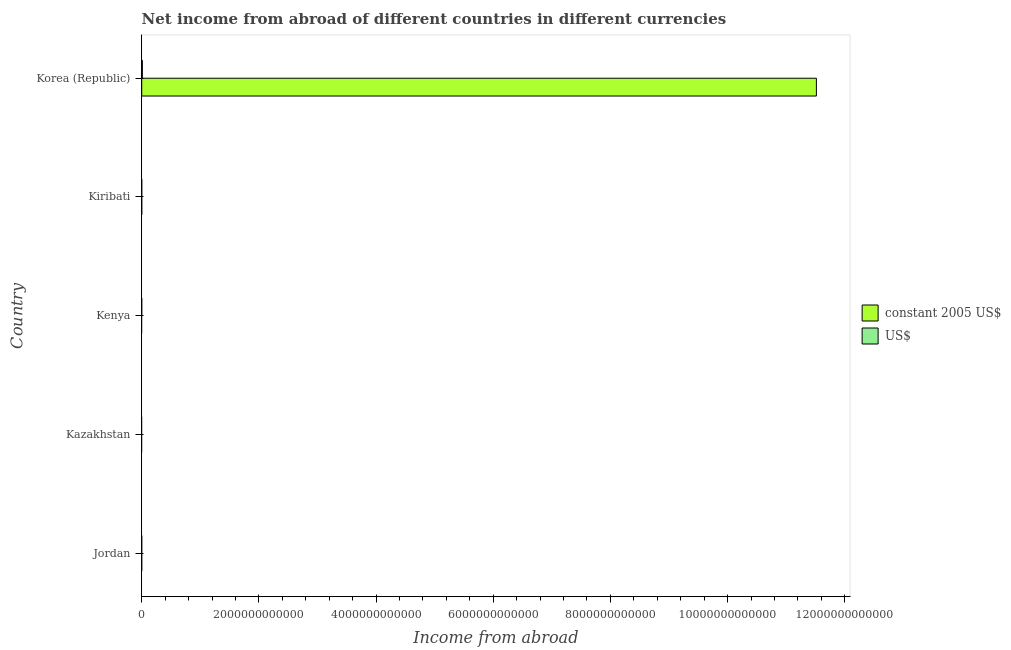How many different coloured bars are there?
Offer a terse response. 2. Are the number of bars per tick equal to the number of legend labels?
Make the answer very short. No. What is the label of the 2nd group of bars from the top?
Your answer should be compact. Kiribati. In how many cases, is the number of bars for a given country not equal to the number of legend labels?
Ensure brevity in your answer.  3. Across all countries, what is the maximum income from abroad in constant 2005 us$?
Offer a very short reply. 1.15e+13. In which country was the income from abroad in us$ maximum?
Give a very brief answer. Korea (Republic). What is the total income from abroad in us$ in the graph?
Provide a short and direct response. 1.11e+1. What is the difference between the income from abroad in us$ in Kiribati and that in Korea (Republic)?
Keep it short and to the point. -1.08e+1. What is the difference between the income from abroad in constant 2005 us$ in Kenya and the income from abroad in us$ in Kiribati?
Your response must be concise. -1.41e+08. What is the average income from abroad in constant 2005 us$ per country?
Ensure brevity in your answer.  2.30e+12. What is the difference between the income from abroad in us$ and income from abroad in constant 2005 us$ in Kiribati?
Offer a terse response. -1.55e+07. In how many countries, is the income from abroad in us$ greater than 5600000000000 units?
Make the answer very short. 0. What is the difference between the highest and the lowest income from abroad in constant 2005 us$?
Provide a short and direct response. 1.15e+13. In how many countries, is the income from abroad in constant 2005 us$ greater than the average income from abroad in constant 2005 us$ taken over all countries?
Your answer should be compact. 1. Are all the bars in the graph horizontal?
Make the answer very short. Yes. How many countries are there in the graph?
Give a very brief answer. 5. What is the difference between two consecutive major ticks on the X-axis?
Offer a terse response. 2.00e+12. Does the graph contain any zero values?
Offer a very short reply. Yes. What is the title of the graph?
Keep it short and to the point. Net income from abroad of different countries in different currencies. Does "Non-resident workers" appear as one of the legend labels in the graph?
Your response must be concise. No. What is the label or title of the X-axis?
Ensure brevity in your answer.  Income from abroad. What is the Income from abroad in constant 2005 US$ in Jordan?
Your answer should be very brief. 0. What is the Income from abroad in US$ in Jordan?
Your answer should be very brief. 0. What is the Income from abroad of US$ in Kazakhstan?
Provide a short and direct response. 0. What is the Income from abroad in constant 2005 US$ in Kenya?
Provide a short and direct response. 0. What is the Income from abroad in US$ in Kenya?
Give a very brief answer. 0. What is the Income from abroad of constant 2005 US$ in Kiribati?
Ensure brevity in your answer.  1.57e+08. What is the Income from abroad of US$ in Kiribati?
Your answer should be very brief. 1.41e+08. What is the Income from abroad of constant 2005 US$ in Korea (Republic)?
Give a very brief answer. 1.15e+13. What is the Income from abroad in US$ in Korea (Republic)?
Make the answer very short. 1.09e+1. Across all countries, what is the maximum Income from abroad in constant 2005 US$?
Your response must be concise. 1.15e+13. Across all countries, what is the maximum Income from abroad of US$?
Provide a succinct answer. 1.09e+1. What is the total Income from abroad in constant 2005 US$ in the graph?
Your answer should be very brief. 1.15e+13. What is the total Income from abroad of US$ in the graph?
Provide a short and direct response. 1.11e+1. What is the difference between the Income from abroad in constant 2005 US$ in Kiribati and that in Korea (Republic)?
Ensure brevity in your answer.  -1.15e+13. What is the difference between the Income from abroad in US$ in Kiribati and that in Korea (Republic)?
Your answer should be very brief. -1.08e+1. What is the difference between the Income from abroad of constant 2005 US$ in Kiribati and the Income from abroad of US$ in Korea (Republic)?
Your response must be concise. -1.08e+1. What is the average Income from abroad of constant 2005 US$ per country?
Your answer should be compact. 2.30e+12. What is the average Income from abroad in US$ per country?
Make the answer very short. 2.22e+09. What is the difference between the Income from abroad in constant 2005 US$ and Income from abroad in US$ in Kiribati?
Provide a succinct answer. 1.55e+07. What is the difference between the Income from abroad of constant 2005 US$ and Income from abroad of US$ in Korea (Republic)?
Your response must be concise. 1.15e+13. What is the ratio of the Income from abroad in constant 2005 US$ in Kiribati to that in Korea (Republic)?
Provide a succinct answer. 0. What is the ratio of the Income from abroad of US$ in Kiribati to that in Korea (Republic)?
Keep it short and to the point. 0.01. What is the difference between the highest and the lowest Income from abroad of constant 2005 US$?
Make the answer very short. 1.15e+13. What is the difference between the highest and the lowest Income from abroad in US$?
Offer a very short reply. 1.09e+1. 